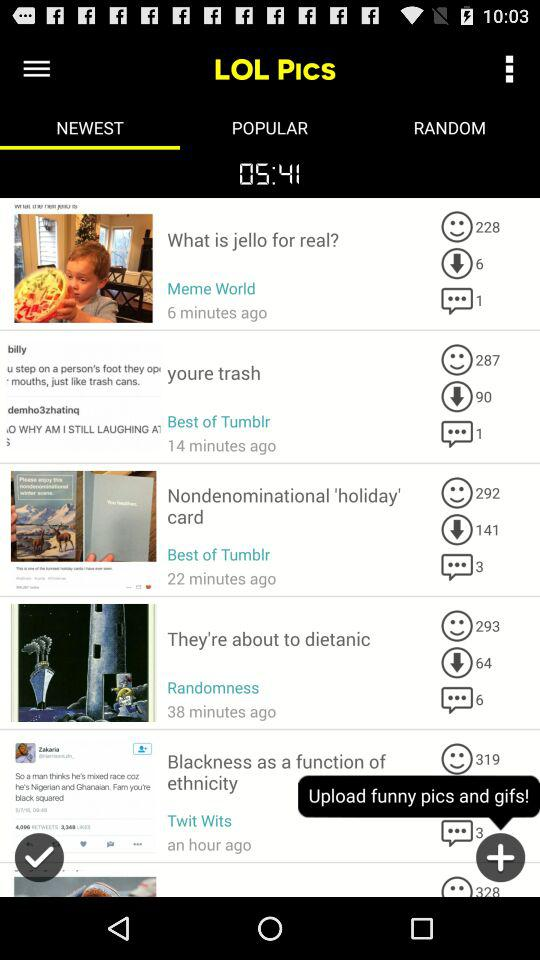Which tab is selected? The selected tab is "NEWEST". 